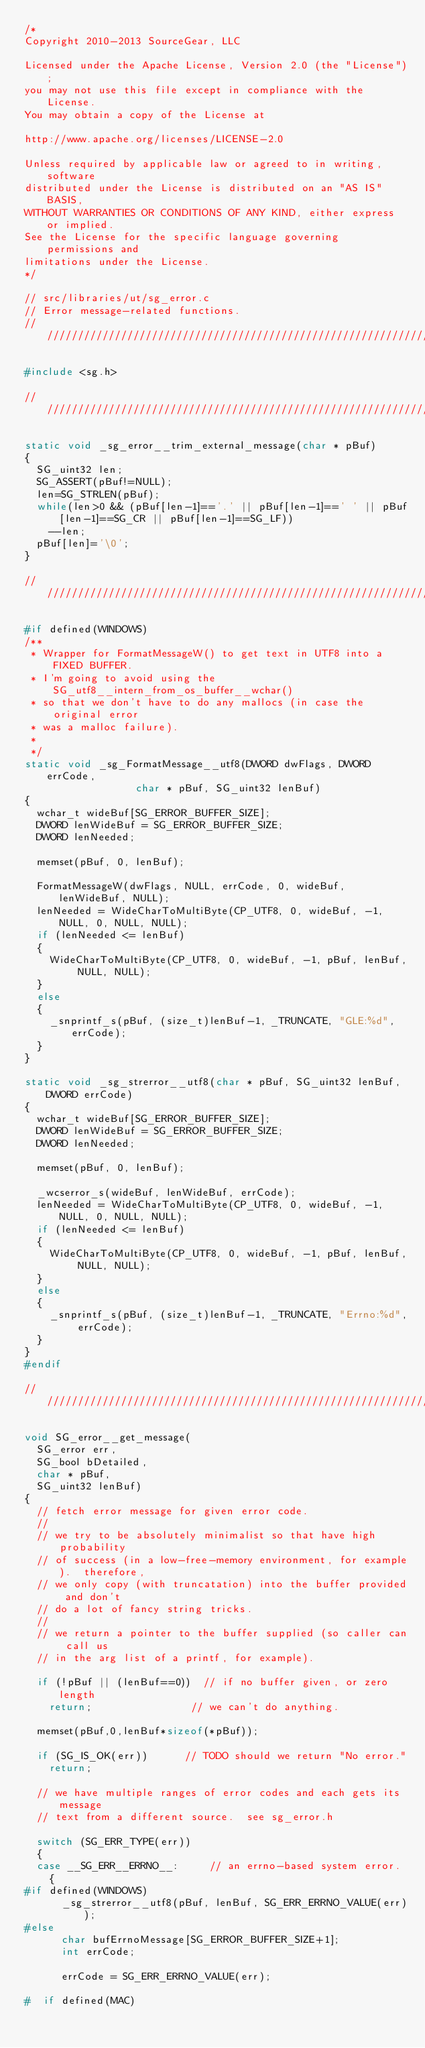Convert code to text. <code><loc_0><loc_0><loc_500><loc_500><_C_>/*
Copyright 2010-2013 SourceGear, LLC

Licensed under the Apache License, Version 2.0 (the "License");
you may not use this file except in compliance with the License.
You may obtain a copy of the License at

http://www.apache.org/licenses/LICENSE-2.0

Unless required by applicable law or agreed to in writing, software
distributed under the License is distributed on an "AS IS" BASIS,
WITHOUT WARRANTIES OR CONDITIONS OF ANY KIND, either express or implied.
See the License for the specific language governing permissions and
limitations under the License.
*/

// src/libraries/ut/sg_error.c
// Error message-related functions.
//////////////////////////////////////////////////////////////////

#include <sg.h>

//////////////////////////////////////////////////////////////////

static void _sg_error__trim_external_message(char * pBuf)
{
	SG_uint32 len;
	SG_ASSERT(pBuf!=NULL);
	len=SG_STRLEN(pBuf);
	while(len>0 && (pBuf[len-1]=='.' || pBuf[len-1]==' ' || pBuf[len-1]==SG_CR || pBuf[len-1]==SG_LF))
		--len;
	pBuf[len]='\0';
}

////////////////////////////////////////////////////////////////

#if defined(WINDOWS)
/**
 * Wrapper for FormatMessageW() to get text in UTF8 into a FIXED BUFFER.
 * I'm going to avoid using the SG_utf8__intern_from_os_buffer__wchar()
 * so that we don't have to do any mallocs (in case the original error
 * was a malloc failure).
 * 
 */
static void _sg_FormatMessage__utf8(DWORD dwFlags, DWORD errCode,
									char * pBuf, SG_uint32 lenBuf)
{
	wchar_t wideBuf[SG_ERROR_BUFFER_SIZE];
	DWORD lenWideBuf = SG_ERROR_BUFFER_SIZE;
	DWORD lenNeeded;

	memset(pBuf, 0, lenBuf);

	FormatMessageW(dwFlags, NULL, errCode, 0, wideBuf, lenWideBuf, NULL);
	lenNeeded = WideCharToMultiByte(CP_UTF8, 0, wideBuf, -1, NULL, 0, NULL, NULL);
	if (lenNeeded <= lenBuf)
	{
		WideCharToMultiByte(CP_UTF8, 0, wideBuf, -1, pBuf, lenBuf, NULL, NULL);
	}
	else
	{
		_snprintf_s(pBuf, (size_t)lenBuf-1, _TRUNCATE, "GLE:%d", errCode);
	}
}

static void _sg_strerror__utf8(char * pBuf, SG_uint32 lenBuf, DWORD errCode)
{
	wchar_t wideBuf[SG_ERROR_BUFFER_SIZE];
	DWORD lenWideBuf = SG_ERROR_BUFFER_SIZE;
	DWORD lenNeeded;

	memset(pBuf, 0, lenBuf);

	_wcserror_s(wideBuf, lenWideBuf, errCode);
	lenNeeded = WideCharToMultiByte(CP_UTF8, 0, wideBuf, -1, NULL, 0, NULL, NULL);
	if (lenNeeded <= lenBuf)
	{
		WideCharToMultiByte(CP_UTF8, 0, wideBuf, -1, pBuf, lenBuf, NULL, NULL);
	}
	else
	{
		_snprintf_s(pBuf, (size_t)lenBuf-1, _TRUNCATE, "Errno:%d", errCode);
	}
}
#endif

////////////////////////////////////////////////////////////////

void SG_error__get_message(
	SG_error err,
	SG_bool bDetailed,
	char * pBuf,
	SG_uint32 lenBuf)
{
	// fetch error message for given error code.
	//
	// we try to be absolutely minimalist so that have high probability
	// of success (in a low-free-memory environment, for example).  therefore,
	// we only copy (with truncatation) into the buffer provided and don't
	// do a lot of fancy string tricks.
	//
	// we return a pointer to the buffer supplied (so caller can call us
	// in the arg list of a printf, for example).

	if (!pBuf || (lenBuf==0))  // if no buffer given, or zero length
		return;                // we can't do anything.

	memset(pBuf,0,lenBuf*sizeof(*pBuf));

	if (SG_IS_OK(err))			// TODO should we return "No error."
		return;

	// we have multiple ranges of error codes and each gets its message
	// text from a different source.  see sg_error.h

	switch (SG_ERR_TYPE(err))
	{
	case __SG_ERR__ERRNO__:			// an errno-based system error.
		{
#if defined(WINDOWS)
			_sg_strerror__utf8(pBuf, lenBuf, SG_ERR_ERRNO_VALUE(err));
#else
			char bufErrnoMessage[SG_ERROR_BUFFER_SIZE+1];
			int errCode;

			errCode = SG_ERR_ERRNO_VALUE(err);

#  if defined(MAC)</code> 